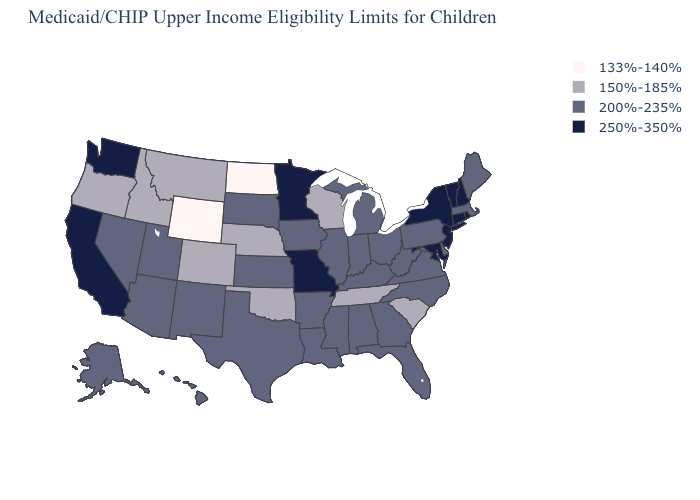What is the lowest value in the South?
Concise answer only. 150%-185%. Name the states that have a value in the range 200%-235%?
Be succinct. Alabama, Alaska, Arizona, Arkansas, Delaware, Florida, Georgia, Hawaii, Illinois, Indiana, Iowa, Kansas, Kentucky, Louisiana, Maine, Massachusetts, Michigan, Mississippi, Nevada, New Mexico, North Carolina, Ohio, Pennsylvania, South Dakota, Texas, Utah, Virginia, West Virginia. How many symbols are there in the legend?
Short answer required. 4. Among the states that border New Jersey , which have the highest value?
Answer briefly. New York. Does the first symbol in the legend represent the smallest category?
Write a very short answer. Yes. Which states have the lowest value in the USA?
Answer briefly. North Dakota, Wyoming. Does South Carolina have the lowest value in the South?
Answer briefly. Yes. Does the first symbol in the legend represent the smallest category?
Write a very short answer. Yes. What is the lowest value in the USA?
Short answer required. 133%-140%. What is the value of North Dakota?
Short answer required. 133%-140%. Is the legend a continuous bar?
Write a very short answer. No. Name the states that have a value in the range 200%-235%?
Answer briefly. Alabama, Alaska, Arizona, Arkansas, Delaware, Florida, Georgia, Hawaii, Illinois, Indiana, Iowa, Kansas, Kentucky, Louisiana, Maine, Massachusetts, Michigan, Mississippi, Nevada, New Mexico, North Carolina, Ohio, Pennsylvania, South Dakota, Texas, Utah, Virginia, West Virginia. Name the states that have a value in the range 250%-350%?
Short answer required. California, Connecticut, Maryland, Minnesota, Missouri, New Hampshire, New Jersey, New York, Rhode Island, Vermont, Washington. What is the value of Colorado?
Keep it brief. 150%-185%. What is the highest value in the USA?
Write a very short answer. 250%-350%. 